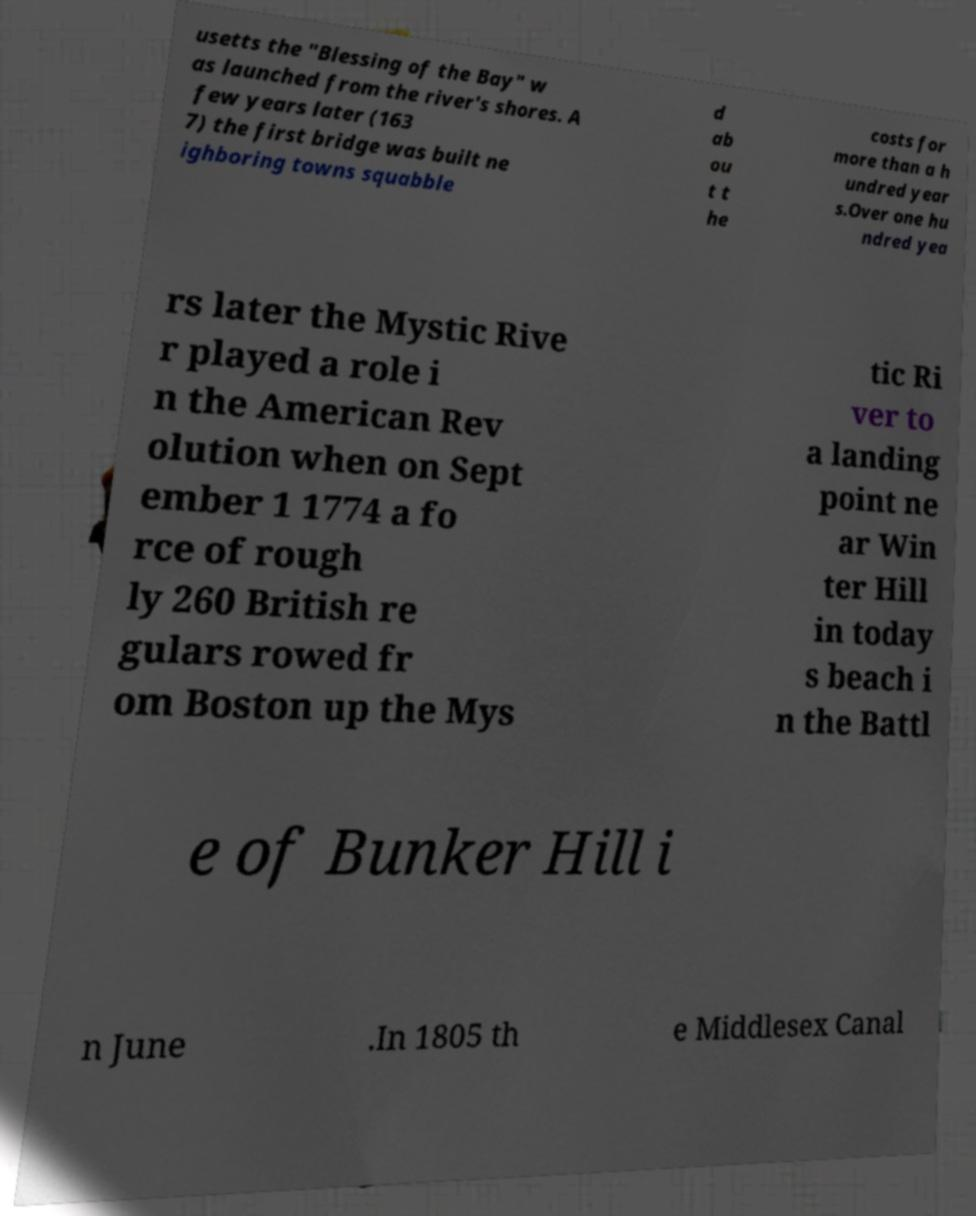Can you accurately transcribe the text from the provided image for me? usetts the "Blessing of the Bay" w as launched from the river's shores. A few years later (163 7) the first bridge was built ne ighboring towns squabble d ab ou t t he costs for more than a h undred year s.Over one hu ndred yea rs later the Mystic Rive r played a role i n the American Rev olution when on Sept ember 1 1774 a fo rce of rough ly 260 British re gulars rowed fr om Boston up the Mys tic Ri ver to a landing point ne ar Win ter Hill in today s beach i n the Battl e of Bunker Hill i n June .In 1805 th e Middlesex Canal 